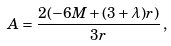Convert formula to latex. <formula><loc_0><loc_0><loc_500><loc_500>A = \frac { 2 ( - 6 M + ( 3 + \lambda ) r ) } { 3 r } \, ,</formula> 